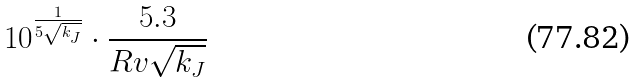<formula> <loc_0><loc_0><loc_500><loc_500>1 0 ^ { \frac { 1 } { 5 \sqrt { k _ { J } } } } \cdot \frac { 5 . 3 } { R v \sqrt { k _ { J } } }</formula> 